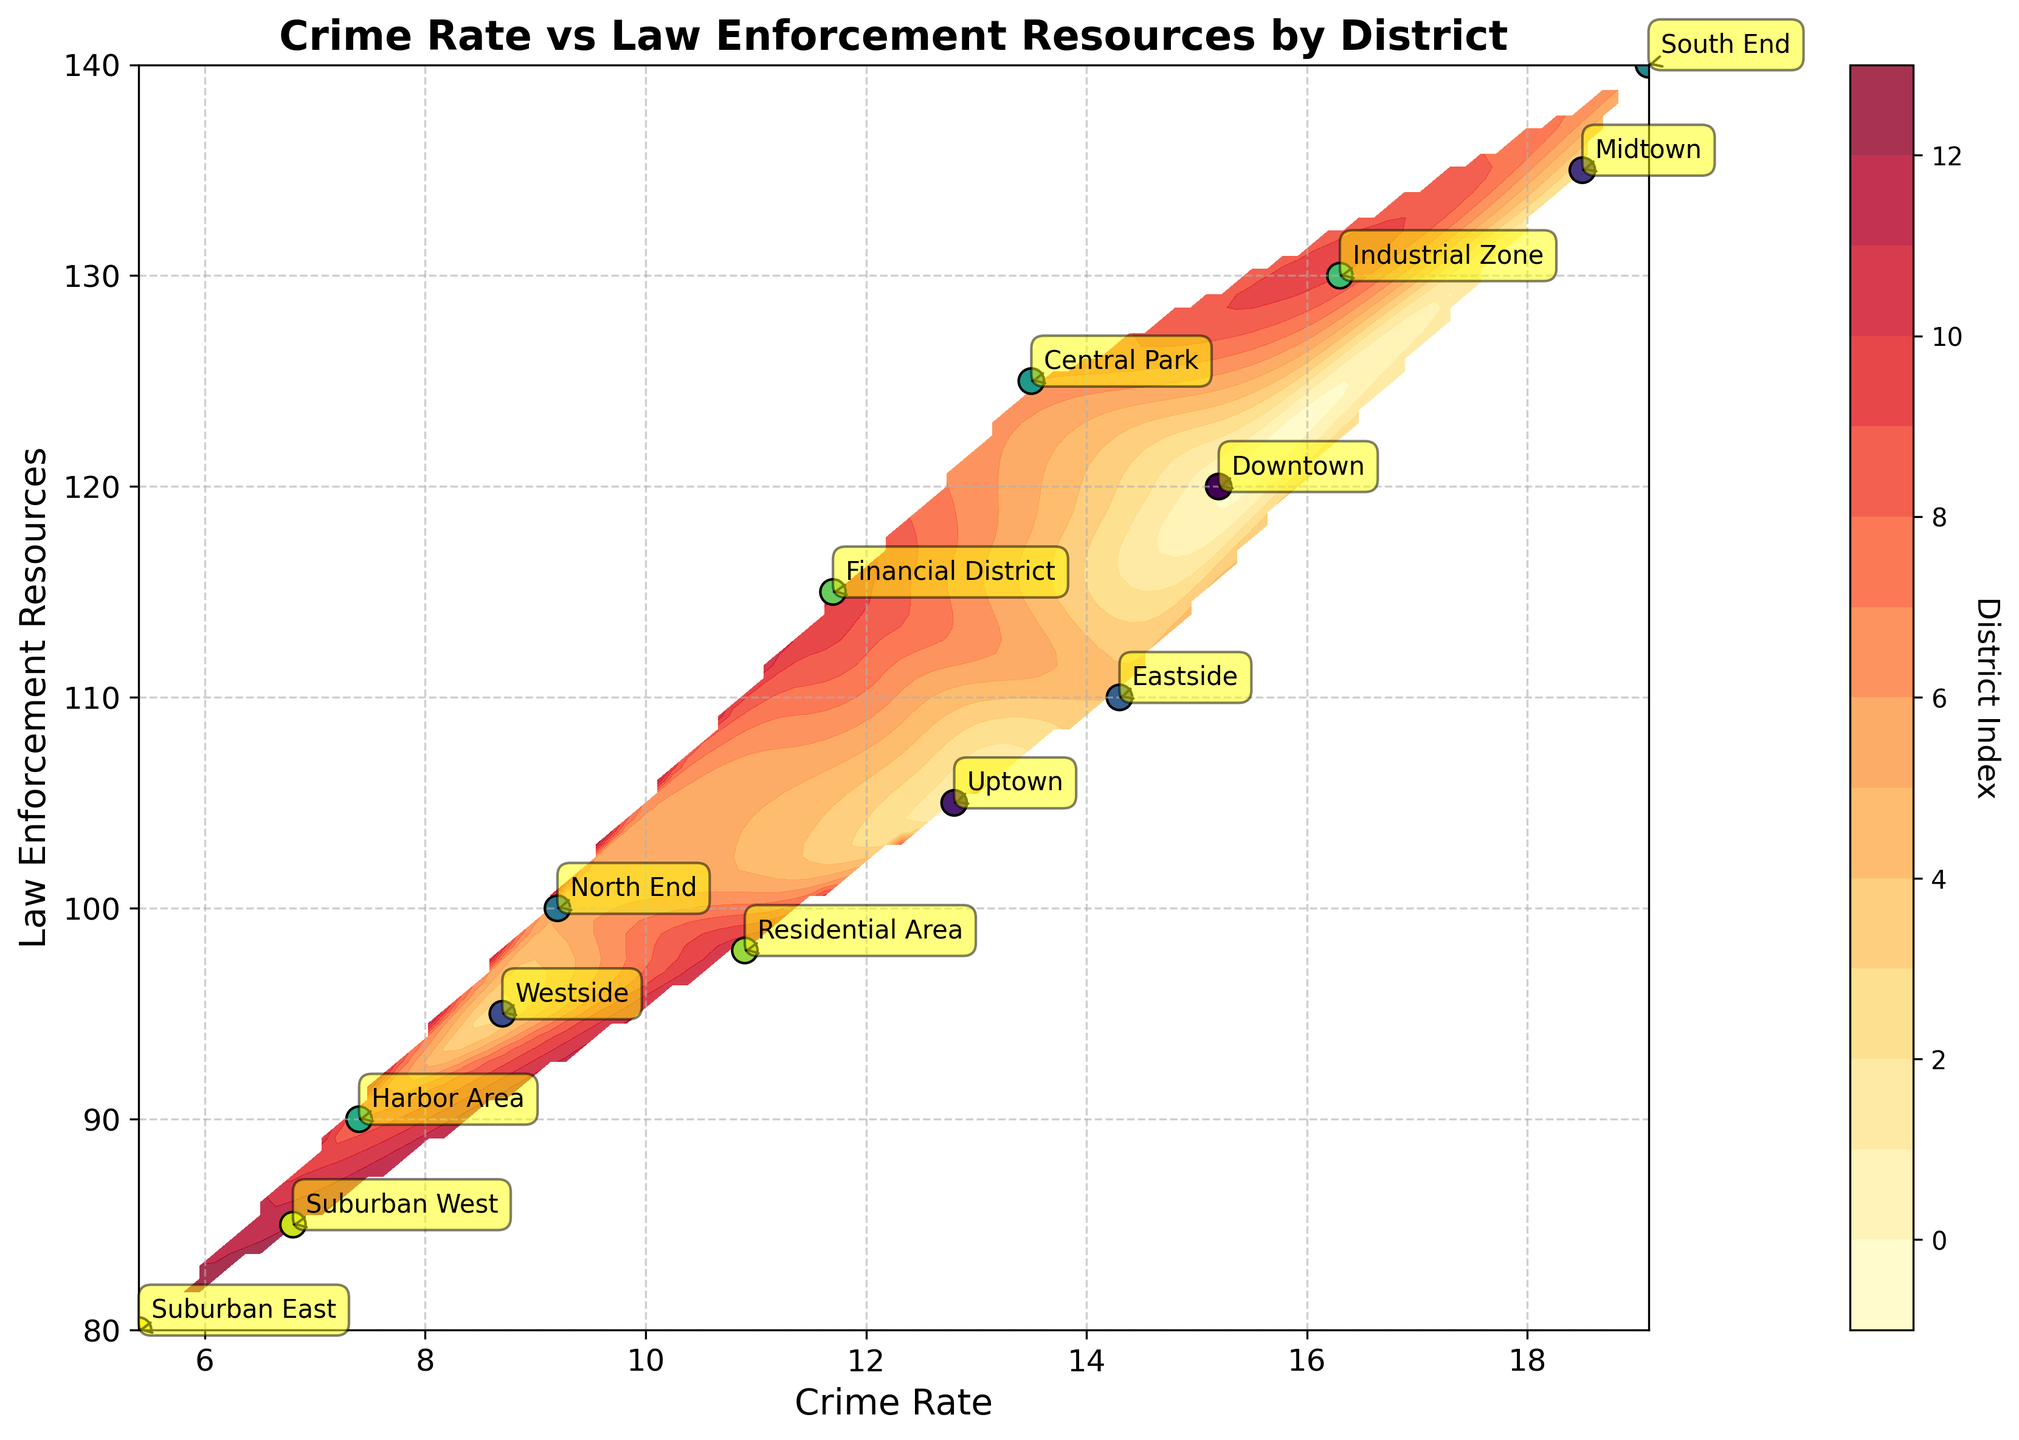How many data points are displayed in the scatter plot? By observing the number of district labels on the plot, we can count each point corresponding to the district names.
Answer: 14 What is the range of the crime rate shown on the x-axis? Looking at the x-axis, the lowest value starts at approximately 5.4 and the highest value is about 19.1.
Answer: 5.4 to 19.1 Which district has the highest crime rate? The point with the highest value on the x-axis has the label "South End" associated with it, indicating the highest crime rate.
Answer: South End What is the relationship between the crime rate and law enforcement resources for the Central Park district? By locating Central Park’s label on the plot, we see it is positioned at (13.5, 125), meaning a crime rate of 13.5 and law enforcement resources of 125.
Answer: 13.5 crime rate, 125 resources Which district has the lowest law enforcement resources, and what is its crime rate? The point with the lowest value on the y-axis is "Suburban East," positioned at (5.4, 80), indicating the lowest law enforcement resources and a corresponding crime rate of 5.4.
Answer: Suburban East, 5.4 Is there a general trend between the crime rate and law enforcement resources across districts? Observing the general spread and alignment of points, there seems to be no clear linear trend, indicating a non-obvious relationship.
Answer: No clear trend How does the law enforcement resource allocation for Harbor Area compare to Industrial Zone? Harbor Area is at (7.4, 90) and Industrial Zone is at (16.3, 130). Comparing the y-values, resources for Harbor Area are lower by 40 units.
Answer: Harbor Area has 40 less resources than Industrial Zone What’s the difference in crime rates between Midtown and Westside? Midtown is at (18.5, 135), and Westside is at (8.7, 95). Subtracting these values, 18.5 - 8.7 gives us a difference of 9.8.
Answer: 9.8 Which district lies closest to the average values of crime rate and law enforcement resources in the plot? Calculate the average crime rate by adding all crime rates and dividing by 14, and similarly for resources. Then identify the closest district on the plot based on visual proximity. The averages are approximately (12.5, 110). Central Park is closest to these values.
Answer: Central Park 